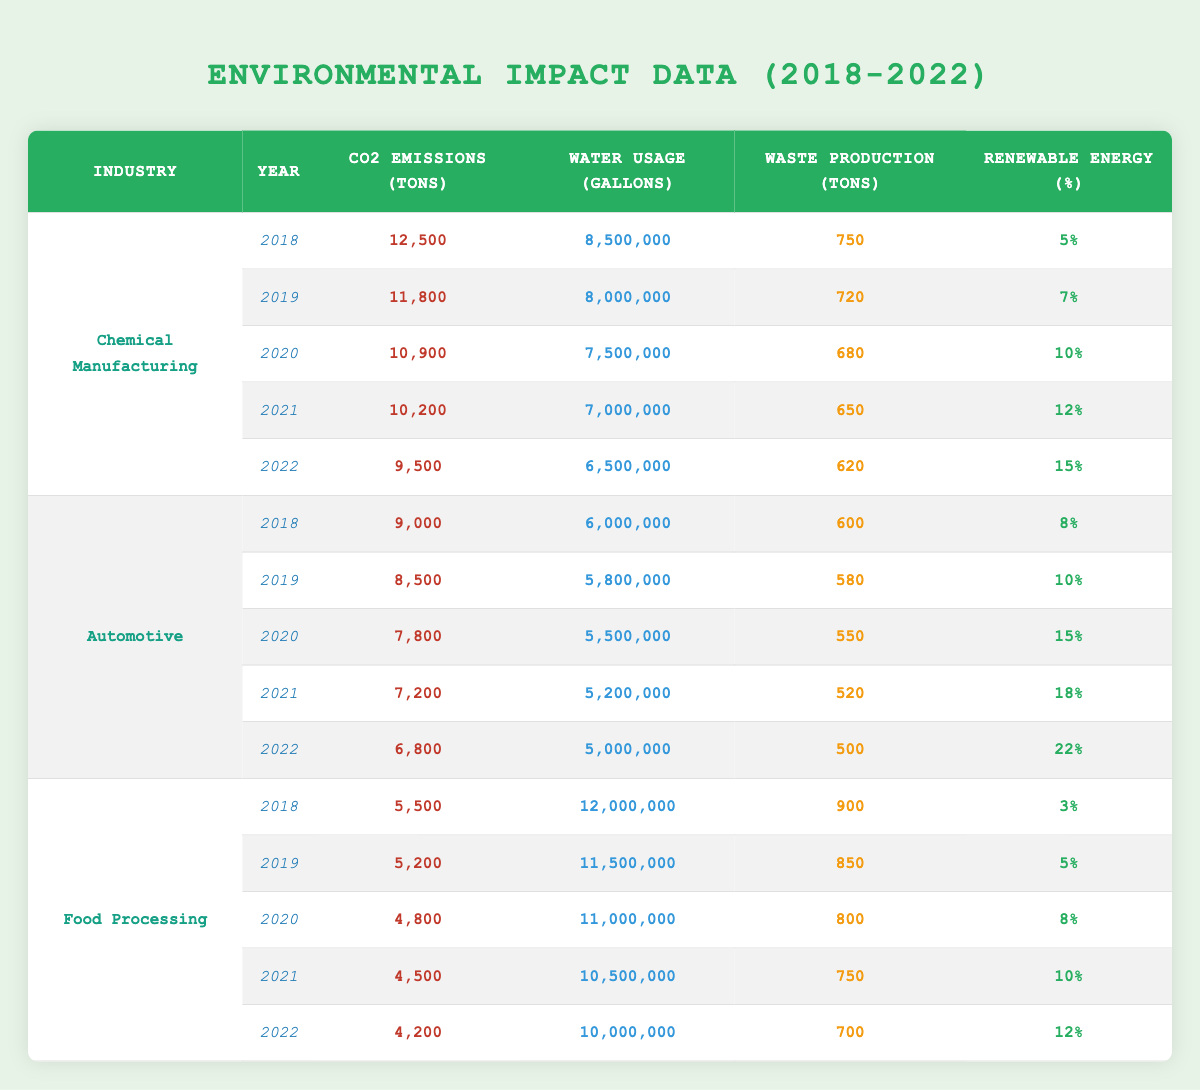What are the CO2 emissions for GreenDrive Motors in 2021? The table lists the data for GreenDrive Motors under the Automotive industry for the year 2021, showing CO2 emissions amounting to 7,200 tons.
Answer: 7,200 tons Which industry had the highest CO2 emissions in 2018? By checking the emissions for each industry in 2018, Chemical Manufacturing showed emissions of 12,500 tons, which is higher than the other industries listed for that year.
Answer: Chemical Manufacturing What is the total Waste Production for NatureBite Foods from 2018 to 2022? Summing the waste production for NatureBite Foods over the five years: 900 + 850 + 800 + 750 + 700 = 4,000 tons.
Answer: 4,000 tons Did GreenDrive Motors increase or decrease its Renewable Energy Percentage from 2018 to 2022? Comparing the Renewable Energy Percentages: 8% in 2018, 10% in 2019, 15% in 2020, 18% in 2021, and 22% in 2022 indicates a consistent increase over the years.
Answer: Increase What is the average Water Usage (in gallons) for the Chemical Manufacturing industry over the years? The water usage amounts are: 8,500,000 (2018), 8,000,000 (2019), 7,500,000 (2020), 7,000,000 (2021), and 6,500,000 (2022). Adding them gives 37,500,000 total for 5 years. Dividing by 5 results in an average of 7,500,000 gallons.
Answer: 7,500,000 gallons What is the percentage decrease in CO2 emissions for the Automotive industry from 2018 to 2022? The CO2 emissions were 9,000 tons in 2018 and 6,800 tons in 2022. The decrease is 9,000 - 6,800 = 2,200 tons. To find the percentage decrease: (2,200 / 9,000) * 100 = 24.44%.
Answer: 24.44% Is the total Water Usage in 2019 higher than in 2020 for the Food Processing industry? The water usage for Food Processing in 2019 was 11,500,000 gallons, and in 2020 it was 11,000,000 gallons. Since 11,500,000 is greater than 11,000,000, the answer is yes.
Answer: Yes Which year saw the least Waste Production for the Chemical Manufacturing industry? The waste production amounts are: 750 (2018), 720 (2019), 680 (2020), 650 (2021), and 620 (2022). The least amount recorded is 620 tons in 2022.
Answer: 2022 How much did CO2 emissions for the Food Processing industry decline from 2018 to 2022? In 2018, CO2 emissions were 5,500 tons and in 2022 they were 4,200 tons. The decline is calculated as 5,500 - 4,200 = 1,300 tons.
Answer: 1,300 tons 